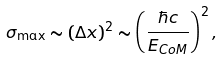<formula> <loc_0><loc_0><loc_500><loc_500>\sigma _ { \max } \sim ( \Delta x ) ^ { 2 } \sim \left ( \frac { \hbar { c } } { E _ { C o M } } \right ) ^ { 2 } ,</formula> 